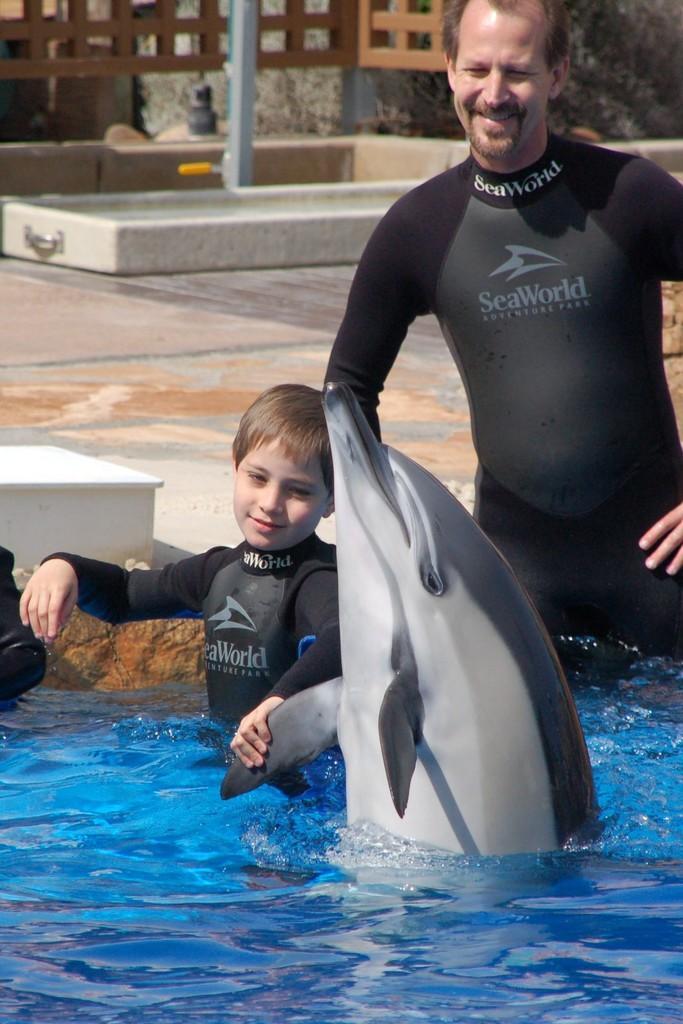In one or two sentences, can you explain what this image depicts? In this image there is a person in the pool, in front of the person there is a child with a dolphin. In the background there is a wooden fence, pole trees and other objects are on the path. 